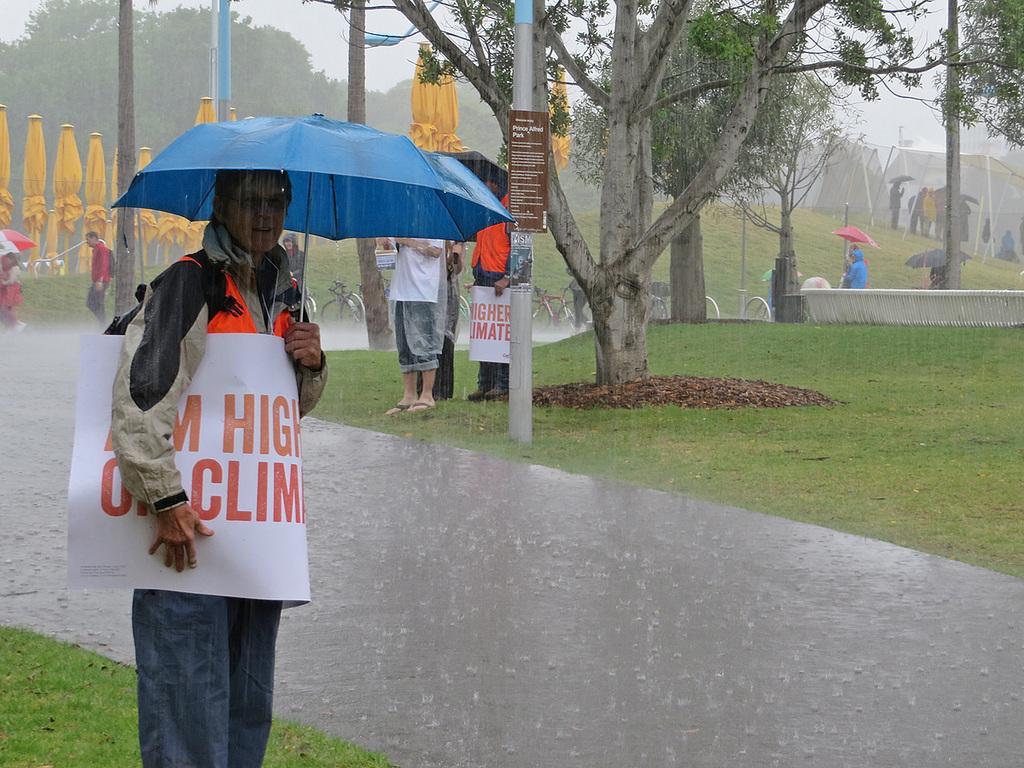Please provide a concise description of this image. In this picture we can see a group of people holding umbrellas with their hands where some are standing and some are walking on the road, trees, bicycles and in the background we can see the sky. 